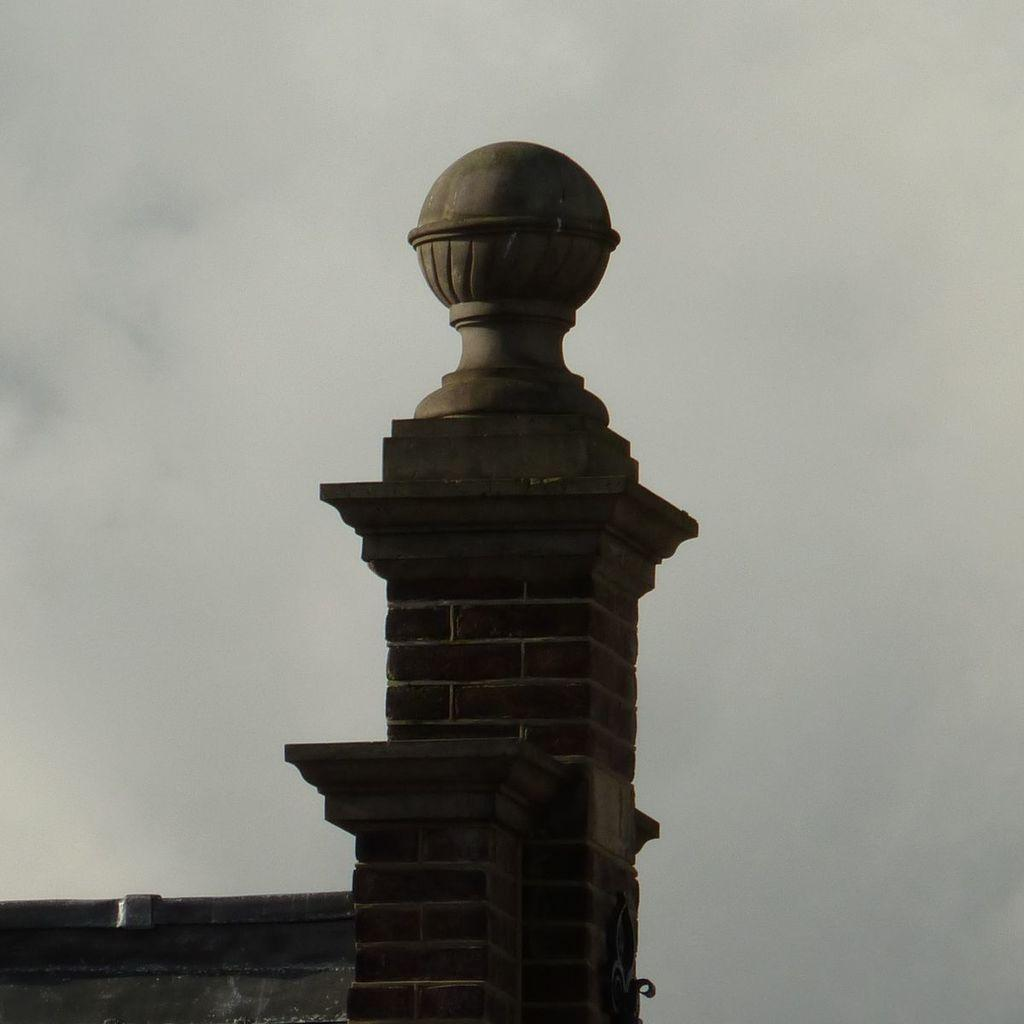What type of structure is visible in the image? The image contains the top of a building. What can be seen in the background of the image? The sky is visible in the background of the image. Where is the vase placed in the image? There is no vase present in the image. What memories might be associated with the building in the image? The image does not provide any information about memories associated with the building. 